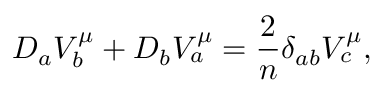Convert formula to latex. <formula><loc_0><loc_0><loc_500><loc_500>D _ { a } V _ { b } ^ { \mu } + D _ { b } V _ { a } ^ { \mu } = { \frac { 2 } { n } } \delta _ { a b } V _ { c } ^ { \mu } ,</formula> 